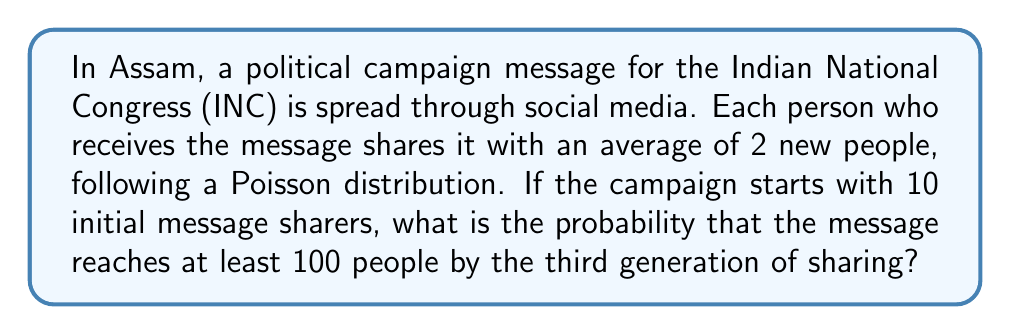Could you help me with this problem? Let's approach this step-by-step using a branching process model:

1) We're dealing with a Galton-Watson branching process where each individual (message sharer) produces offspring (new sharers) according to a Poisson distribution with mean $\lambda = 2$.

2) Let $Z_n$ be the number of individuals in the nth generation. We start with $Z_0 = 10$.

3) The total number of individuals reached by the third generation is $S_3 = Z_0 + Z_1 + Z_2 + Z_3$.

4) The expected number of individuals in each generation:
   $E[Z_1] = 10 \cdot 2 = 20$
   $E[Z_2] = 20 \cdot 2 = 40$
   $E[Z_3] = 40 \cdot 2 = 80$

5) The expected total reached: $E[S_3] = 10 + 20 + 40 + 80 = 150$

6) To find the probability of reaching at least 100 people, we need to find $P(S_3 \geq 100)$.

7) For large numbers, we can approximate the distribution of $S_3$ with a normal distribution:
   $S_3 \sim N(\mu, \sigma^2)$

8) The mean $\mu = E[S_3] = 150$

9) The variance $\sigma^2$ can be calculated as:
   $\sigma^2 = 10 + 20 \cdot 3 + 40 \cdot 5 + 80 \cdot 7 = 690$
   (using the property that for a Poisson($\lambda$) offspring distribution, the variance in generation $n$ is $\lambda^n(1+\lambda)^{n-1}$)

10) We can now standardize and use the standard normal distribution:
    $P(S_3 \geq 100) = P(Z \geq \frac{100 - 150}{\sqrt{690}}) = P(Z \geq -1.90)$

11) Using a standard normal table or calculator, we find:
    $P(Z \geq -1.90) \approx 0.9713$

Therefore, the probability that the message reaches at least 100 people by the third generation is approximately 0.9713 or 97.13%.
Answer: 0.9713 